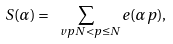<formula> <loc_0><loc_0><loc_500><loc_500>S ( \alpha ) = \sum _ { \ v p N < p \leq N } e ( \alpha p ) ,</formula> 